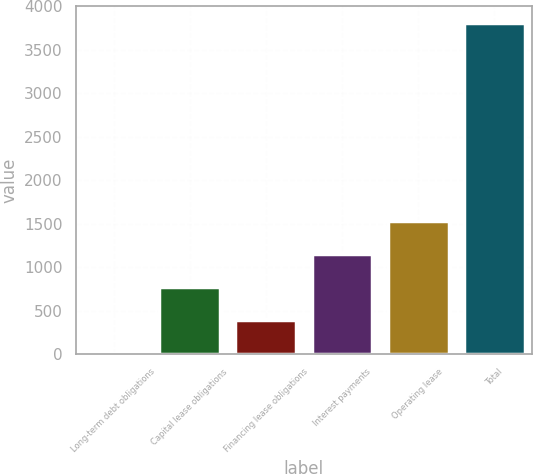Convert chart. <chart><loc_0><loc_0><loc_500><loc_500><bar_chart><fcel>Long-term debt obligations<fcel>Capital lease obligations<fcel>Financing lease obligations<fcel>Interest payments<fcel>Operating lease<fcel>Total<nl><fcel>10<fcel>770.2<fcel>390.1<fcel>1150.3<fcel>1530.4<fcel>3811<nl></chart> 